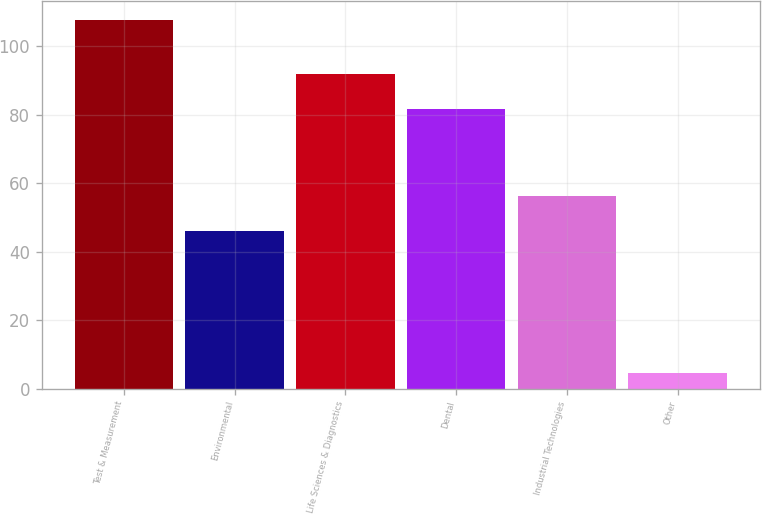Convert chart to OTSL. <chart><loc_0><loc_0><loc_500><loc_500><bar_chart><fcel>Test & Measurement<fcel>Environmental<fcel>Life Sciences & Diagnostics<fcel>Dental<fcel>Industrial Technologies<fcel>Other<nl><fcel>107.7<fcel>45.9<fcel>92.01<fcel>81.7<fcel>56.21<fcel>4.6<nl></chart> 